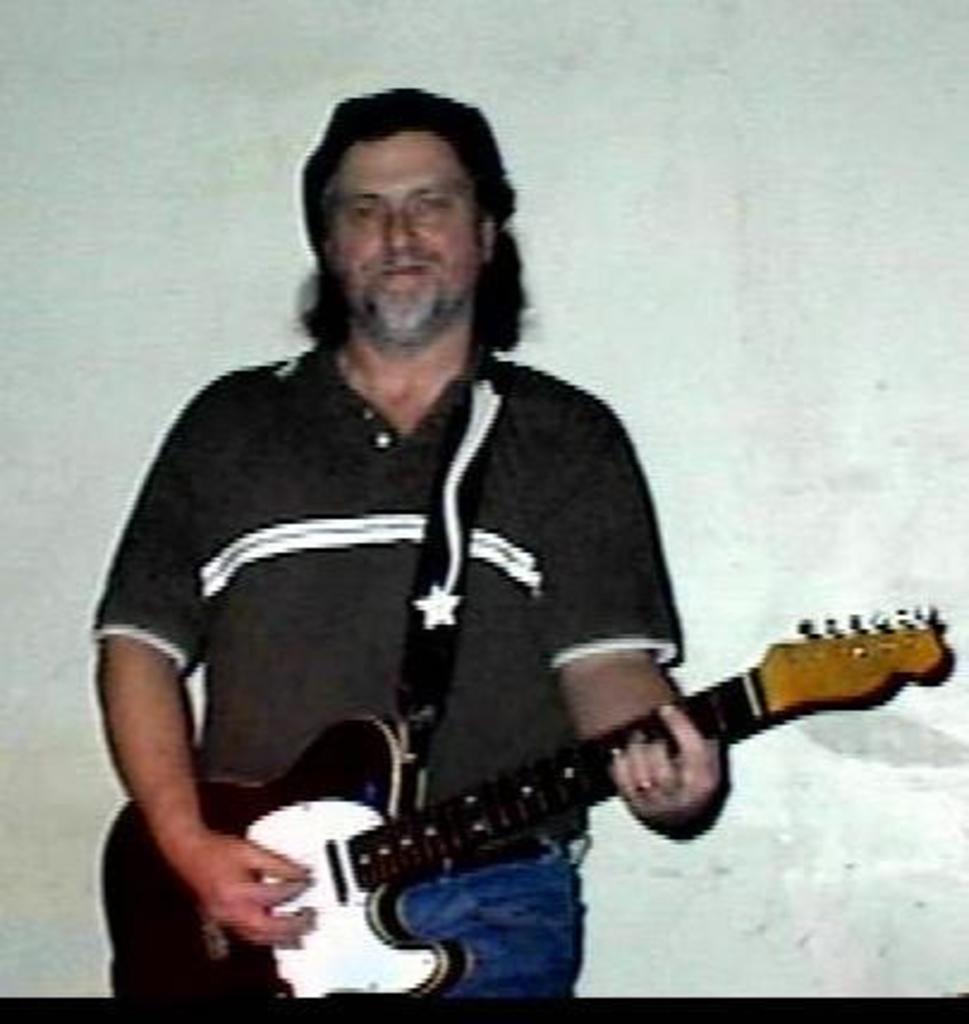Could you give a brief overview of what you see in this image? This image in a room. There is man standing and wearing a black t-shirt. He is playing a guitar. The background is white in color. 